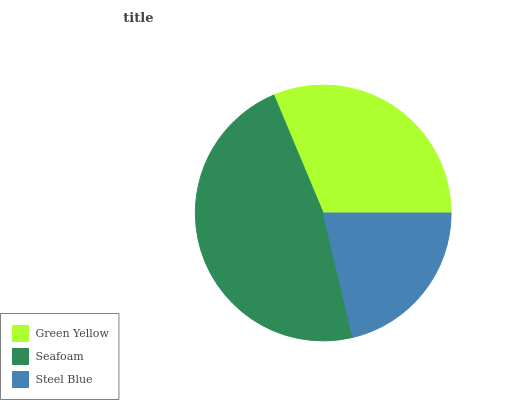Is Steel Blue the minimum?
Answer yes or no. Yes. Is Seafoam the maximum?
Answer yes or no. Yes. Is Seafoam the minimum?
Answer yes or no. No. Is Steel Blue the maximum?
Answer yes or no. No. Is Seafoam greater than Steel Blue?
Answer yes or no. Yes. Is Steel Blue less than Seafoam?
Answer yes or no. Yes. Is Steel Blue greater than Seafoam?
Answer yes or no. No. Is Seafoam less than Steel Blue?
Answer yes or no. No. Is Green Yellow the high median?
Answer yes or no. Yes. Is Green Yellow the low median?
Answer yes or no. Yes. Is Steel Blue the high median?
Answer yes or no. No. Is Seafoam the low median?
Answer yes or no. No. 